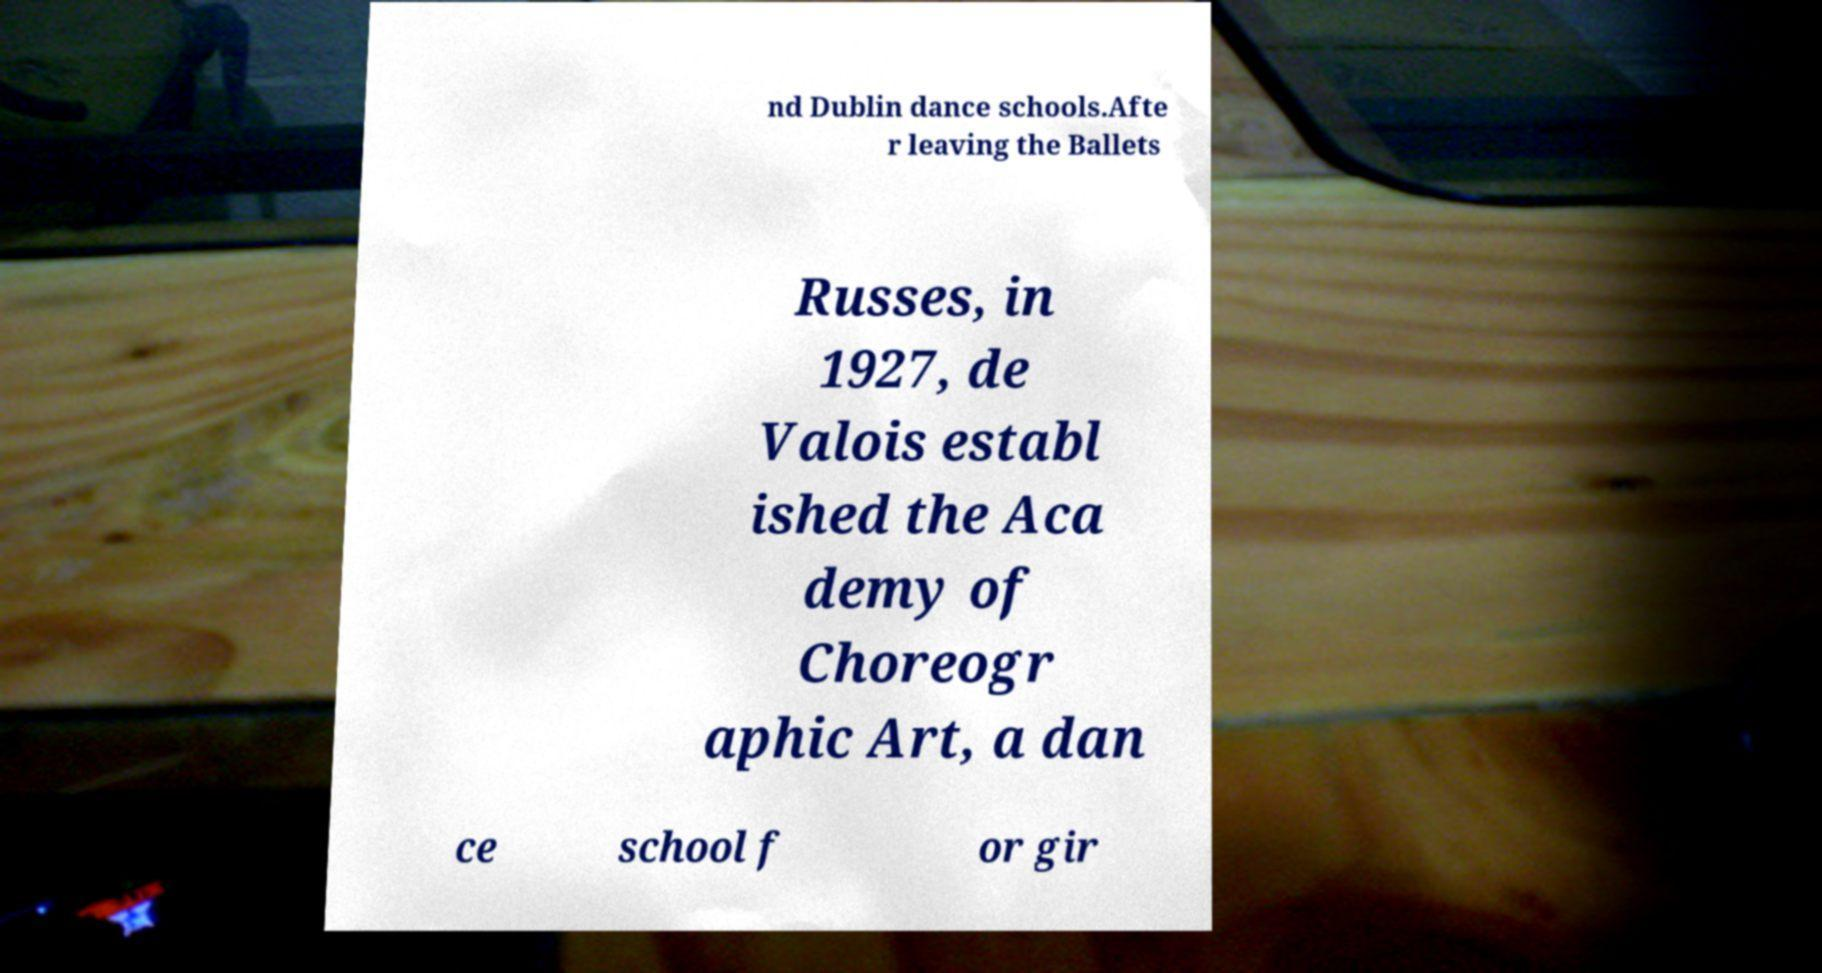For documentation purposes, I need the text within this image transcribed. Could you provide that? nd Dublin dance schools.Afte r leaving the Ballets Russes, in 1927, de Valois establ ished the Aca demy of Choreogr aphic Art, a dan ce school f or gir 